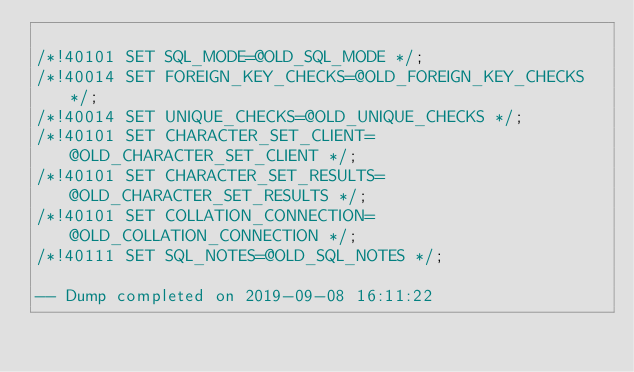<code> <loc_0><loc_0><loc_500><loc_500><_SQL_>
/*!40101 SET SQL_MODE=@OLD_SQL_MODE */;
/*!40014 SET FOREIGN_KEY_CHECKS=@OLD_FOREIGN_KEY_CHECKS */;
/*!40014 SET UNIQUE_CHECKS=@OLD_UNIQUE_CHECKS */;
/*!40101 SET CHARACTER_SET_CLIENT=@OLD_CHARACTER_SET_CLIENT */;
/*!40101 SET CHARACTER_SET_RESULTS=@OLD_CHARACTER_SET_RESULTS */;
/*!40101 SET COLLATION_CONNECTION=@OLD_COLLATION_CONNECTION */;
/*!40111 SET SQL_NOTES=@OLD_SQL_NOTES */;

-- Dump completed on 2019-09-08 16:11:22
</code> 